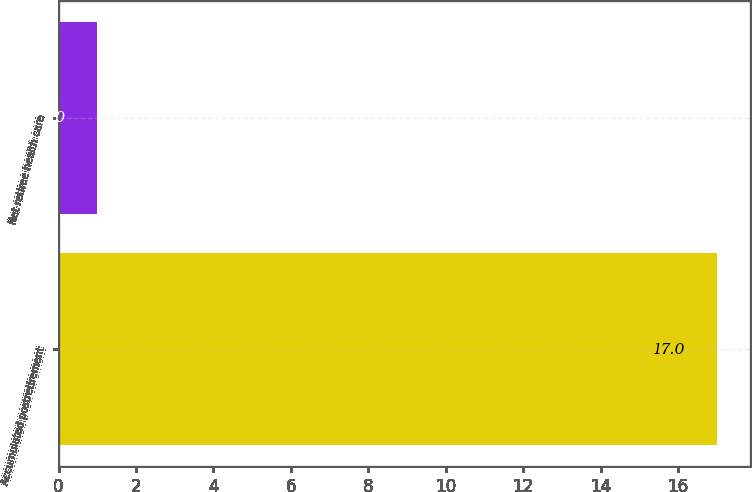Convert chart to OTSL. <chart><loc_0><loc_0><loc_500><loc_500><bar_chart><fcel>Accumulated postretirement<fcel>Net retiree health care<nl><fcel>17<fcel>1<nl></chart> 